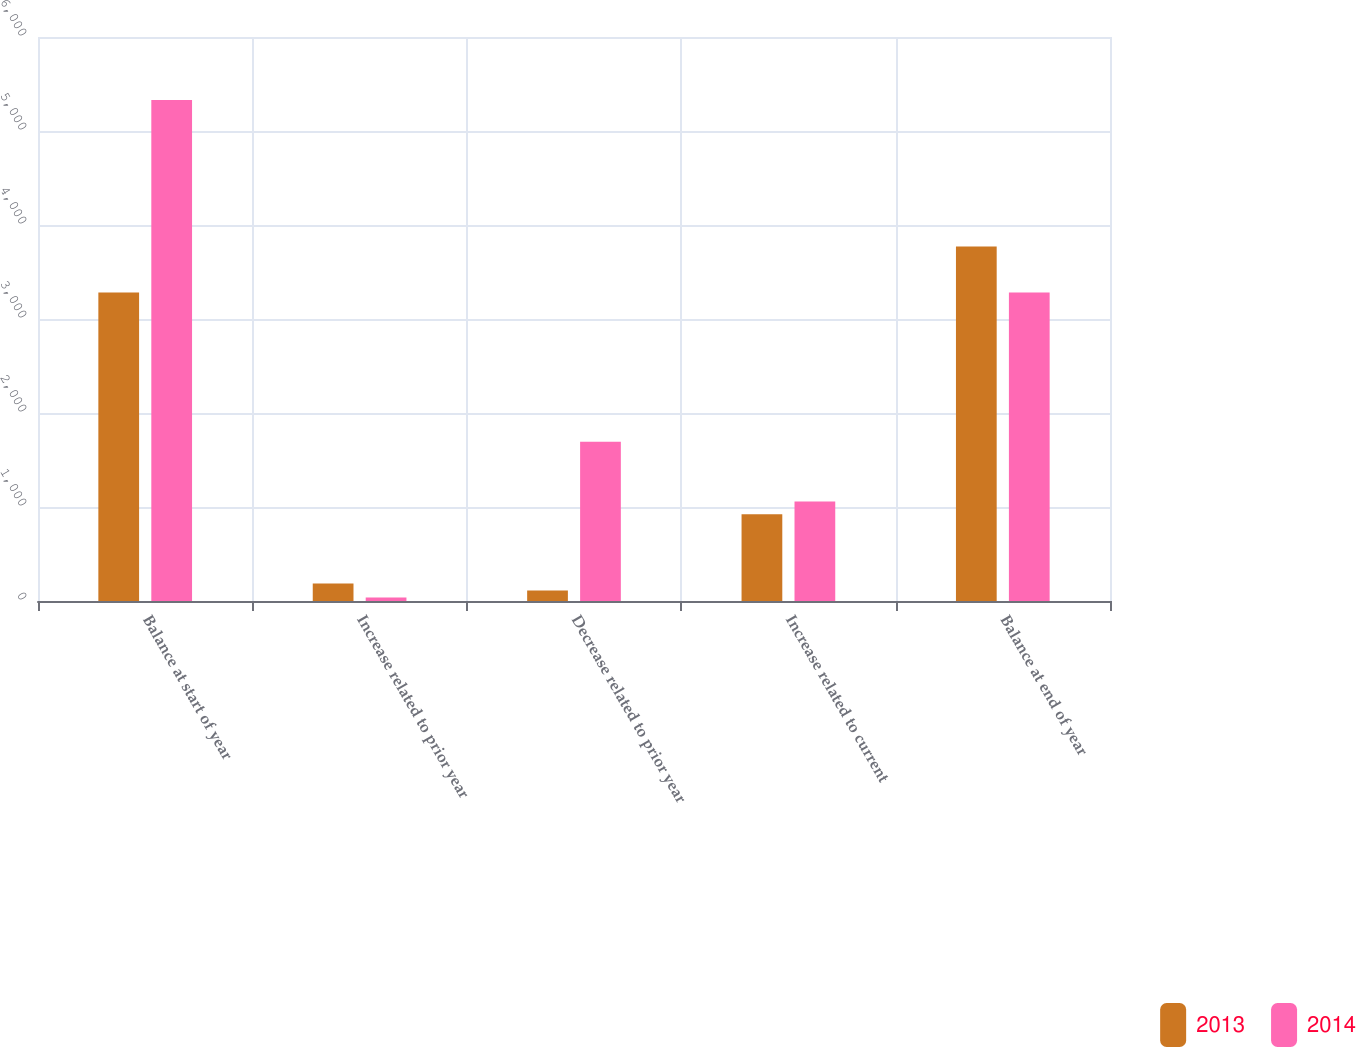Convert chart. <chart><loc_0><loc_0><loc_500><loc_500><stacked_bar_chart><ecel><fcel>Balance at start of year<fcel>Increase related to prior year<fcel>Decrease related to prior year<fcel>Increase related to current<fcel>Balance at end of year<nl><fcel>2013<fcel>3282<fcel>185<fcel>113<fcel>924<fcel>3772<nl><fcel>2014<fcel>5331<fcel>37<fcel>1695<fcel>1058<fcel>3282<nl></chart> 